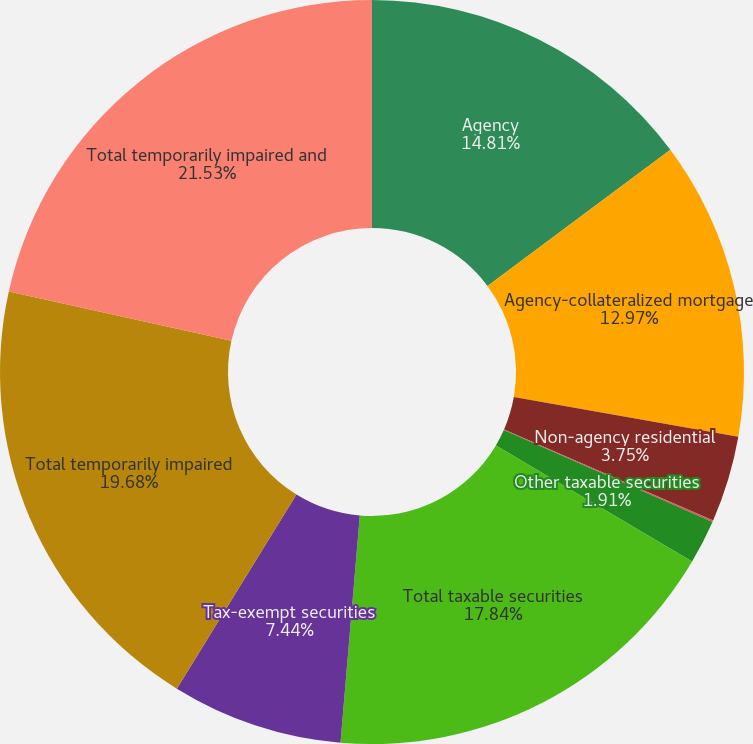<chart> <loc_0><loc_0><loc_500><loc_500><pie_chart><fcel>Agency<fcel>Agency-collateralized mortgage<fcel>Non-agency residential<fcel>Non-US securities<fcel>Other taxable securities<fcel>Total taxable securities<fcel>Tax-exempt securities<fcel>Total temporarily impaired<fcel>Total temporarily impaired and<nl><fcel>14.81%<fcel>12.97%<fcel>3.75%<fcel>0.07%<fcel>1.91%<fcel>17.84%<fcel>7.44%<fcel>19.68%<fcel>21.53%<nl></chart> 